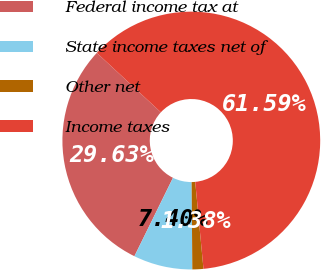Convert chart to OTSL. <chart><loc_0><loc_0><loc_500><loc_500><pie_chart><fcel>Federal income tax at<fcel>State income taxes net of<fcel>Other net<fcel>Income taxes<nl><fcel>29.63%<fcel>7.4%<fcel>1.38%<fcel>61.59%<nl></chart> 